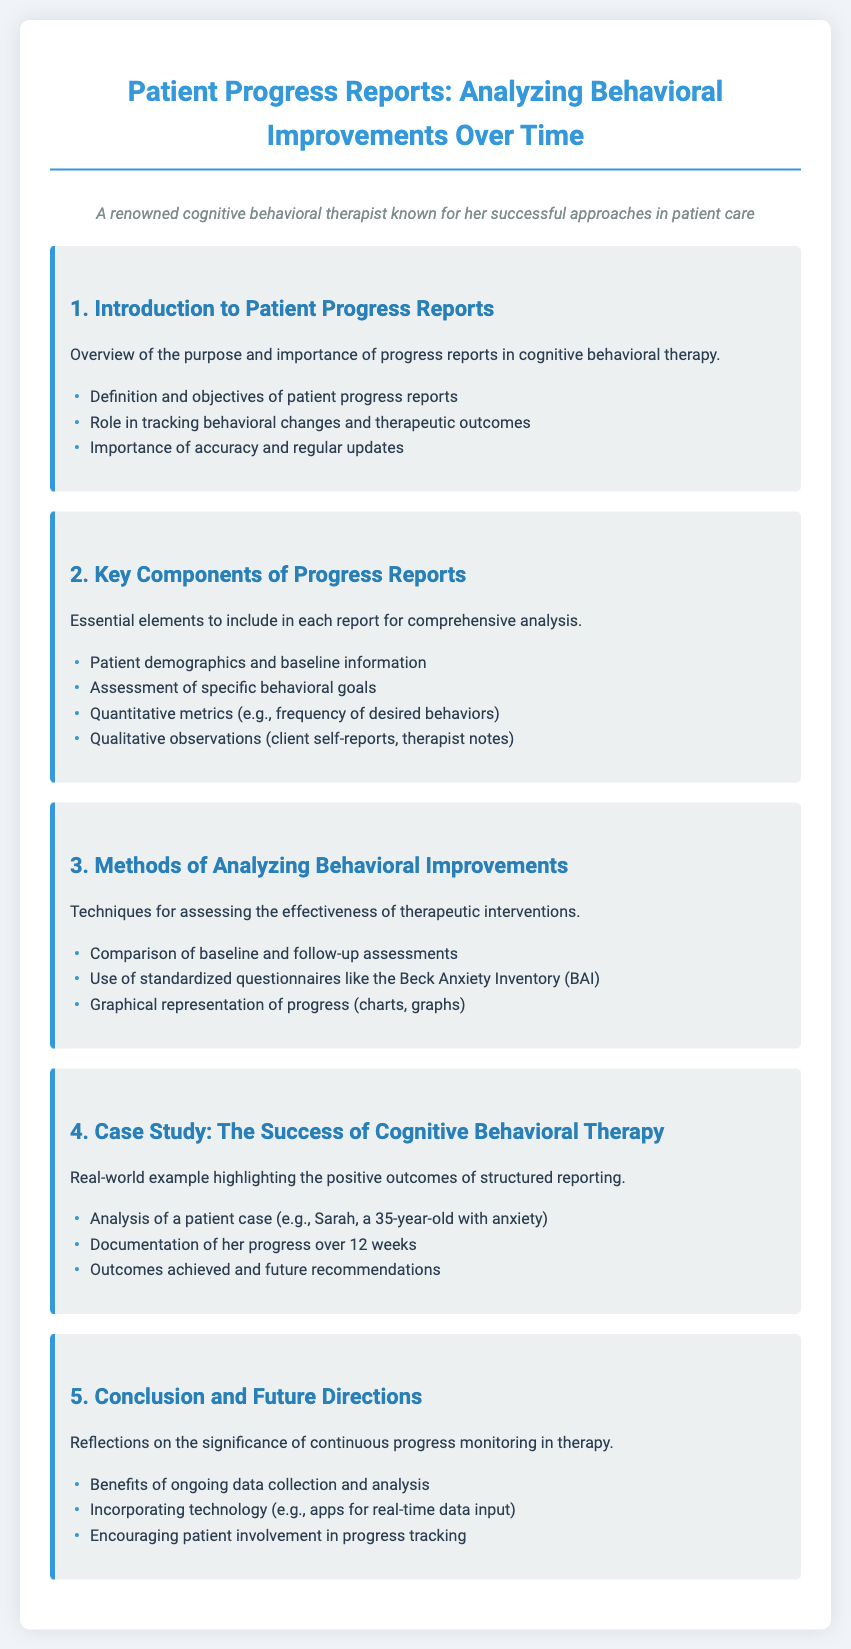What is the title of the document? The title is clearly stated at the top of the document, which is "Patient Progress Reports: Analyzing Behavioral Improvements Over Time."
Answer: Patient Progress Reports: Analyzing Behavioral Improvements Over Time What is one objective of patient progress reports? The document mentions the objectives of patient progress reports, including their role in tracking behavioral changes.
Answer: Role in tracking behavioral changes Which method is mentioned for analyzing behavioral improvements? The document lists techniques under the methods of analyzing behavioral improvements, such as comparing assessments.
Answer: Comparison of baseline and follow-up assessments What is one of the key components included in progress reports? The document specifies essential elements to include in each report, one of which is patient demographics.
Answer: Patient demographics How many weeks does the case study analyze for Sarah's progress? The case study specifically highlights the duration of progress tracking for Sarah.
Answer: 12 weeks What standardized questionnaire is mentioned in the document? The document refers to a standardized questionnaire used for assessing therapy effectiveness.
Answer: Beck Anxiety Inventory What is a benefit of ongoing data collection and analysis mentioned in the conclusion? The document discusses the significance of continuous progress monitoring, which offers various benefits.
Answer: Benefits of ongoing data collection and analysis In what way does the document suggest incorporating technology? The final section of the document mentions the role of technology in enhancing data collection during therapy.
Answer: Apps for real-time data input What is a qualitative observation mentioned that should be included in the reports? The document lists various types of observations for progress reports, specifically mentioning client self-reports.
Answer: Client self-reports 